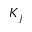Convert formula to latex. <formula><loc_0><loc_0><loc_500><loc_500>K _ { j }</formula> 